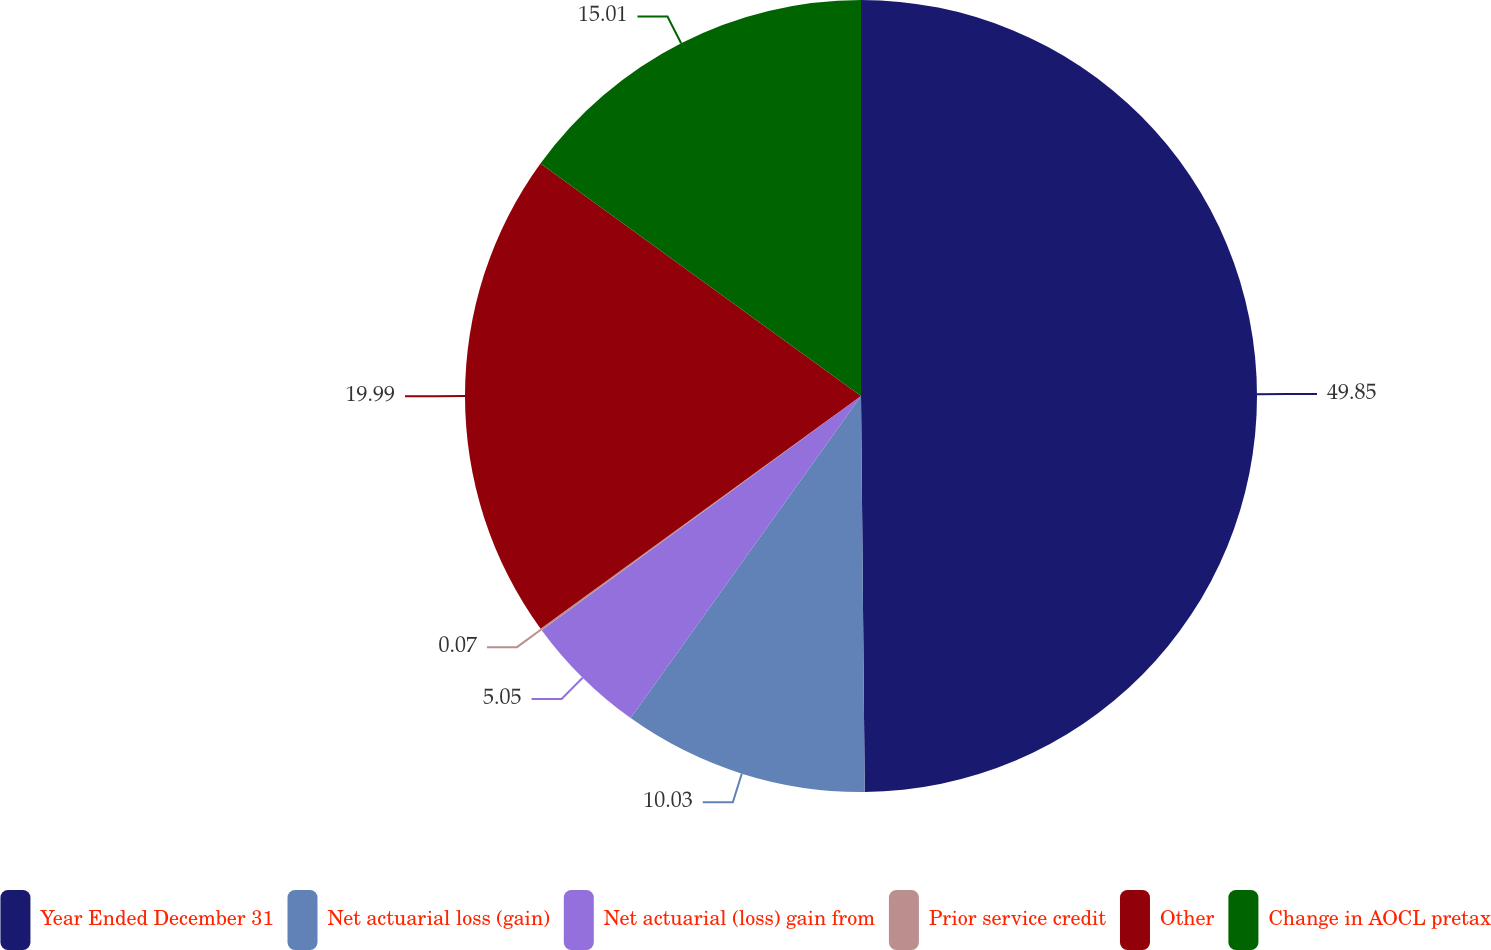Convert chart to OTSL. <chart><loc_0><loc_0><loc_500><loc_500><pie_chart><fcel>Year Ended December 31<fcel>Net actuarial loss (gain)<fcel>Net actuarial (loss) gain from<fcel>Prior service credit<fcel>Other<fcel>Change in AOCL pretax<nl><fcel>49.85%<fcel>10.03%<fcel>5.05%<fcel>0.07%<fcel>19.99%<fcel>15.01%<nl></chart> 